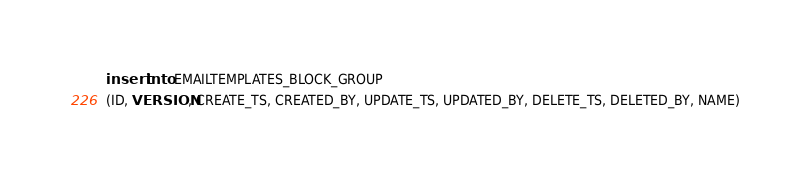Convert code to text. <code><loc_0><loc_0><loc_500><loc_500><_SQL_>insert into EMAILTEMPLATES_BLOCK_GROUP
(ID, VERSION, CREATE_TS, CREATED_BY, UPDATE_TS, UPDATED_BY, DELETE_TS, DELETED_BY, NAME)</code> 